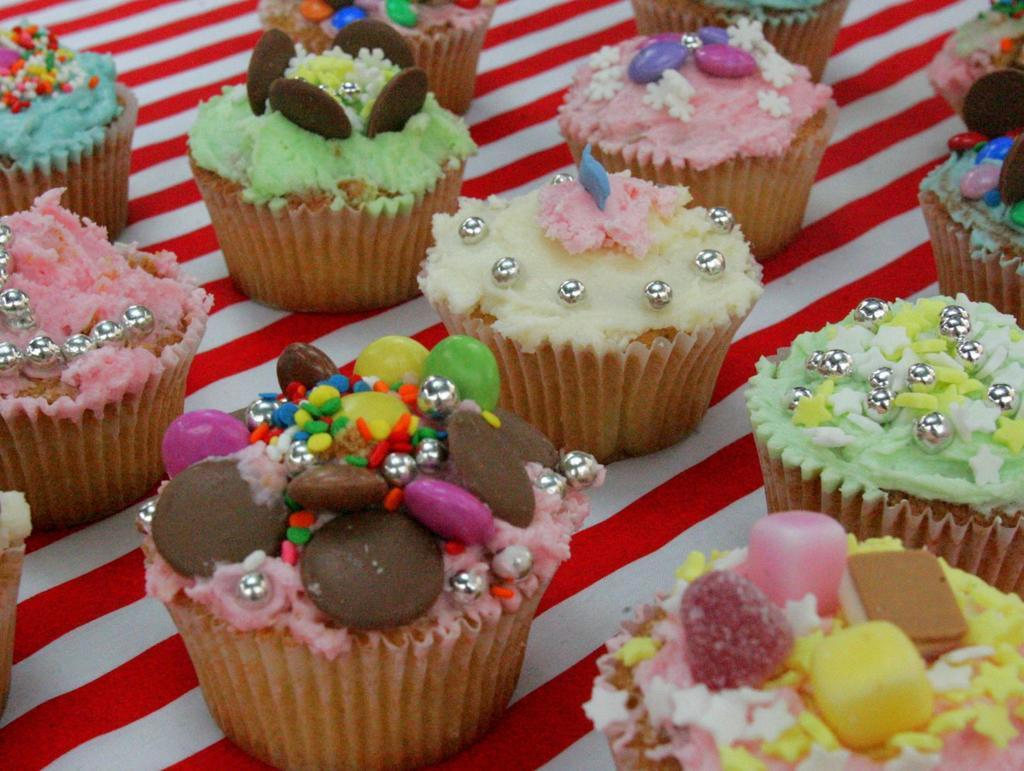What type of dessert can be seen in the image? There are cupcakes in the image. Where are the cupcakes located? The cupcakes are placed on a table. What type of coal can be seen in the image? There is no coal present in the image; it features cupcakes placed on a table. What part of the human body is visible in the image? There are no human body parts visible in the image; it features cupcakes placed on a table. 